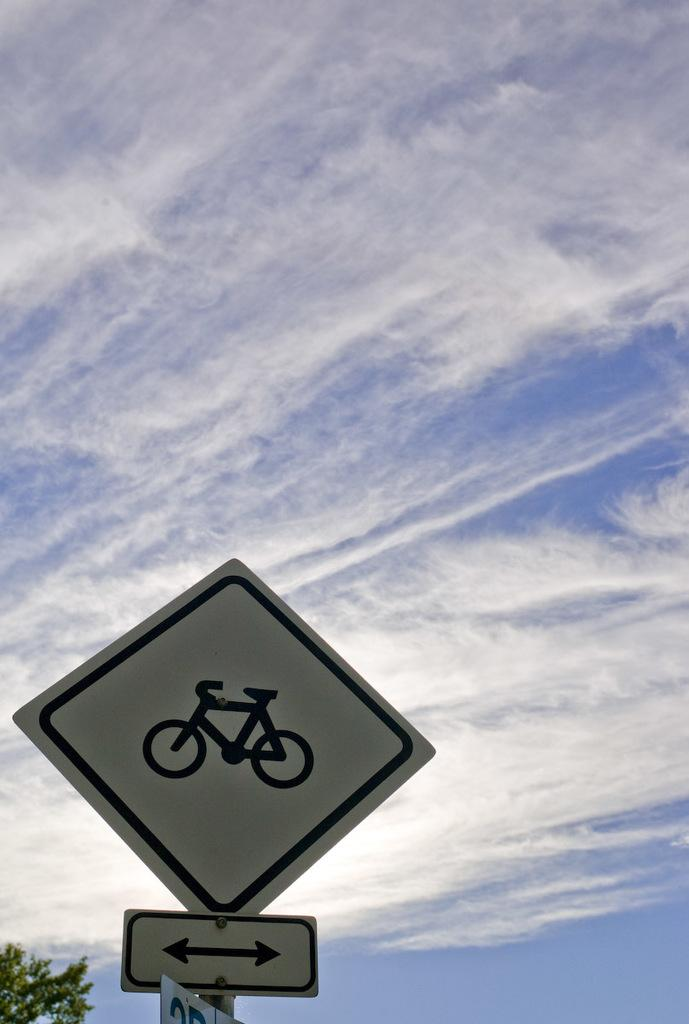What is located at the bottom of the image? There is a sign board at the bottom of the image. What can be seen in the background of the image? There is a sky visible in the background of the image. Where are the leaves of a tree located in the image? The leaves of a tree are at the bottom left corner of the image. What type of glue is being used by the girls in the image? There are no girls or glue present in the image. 